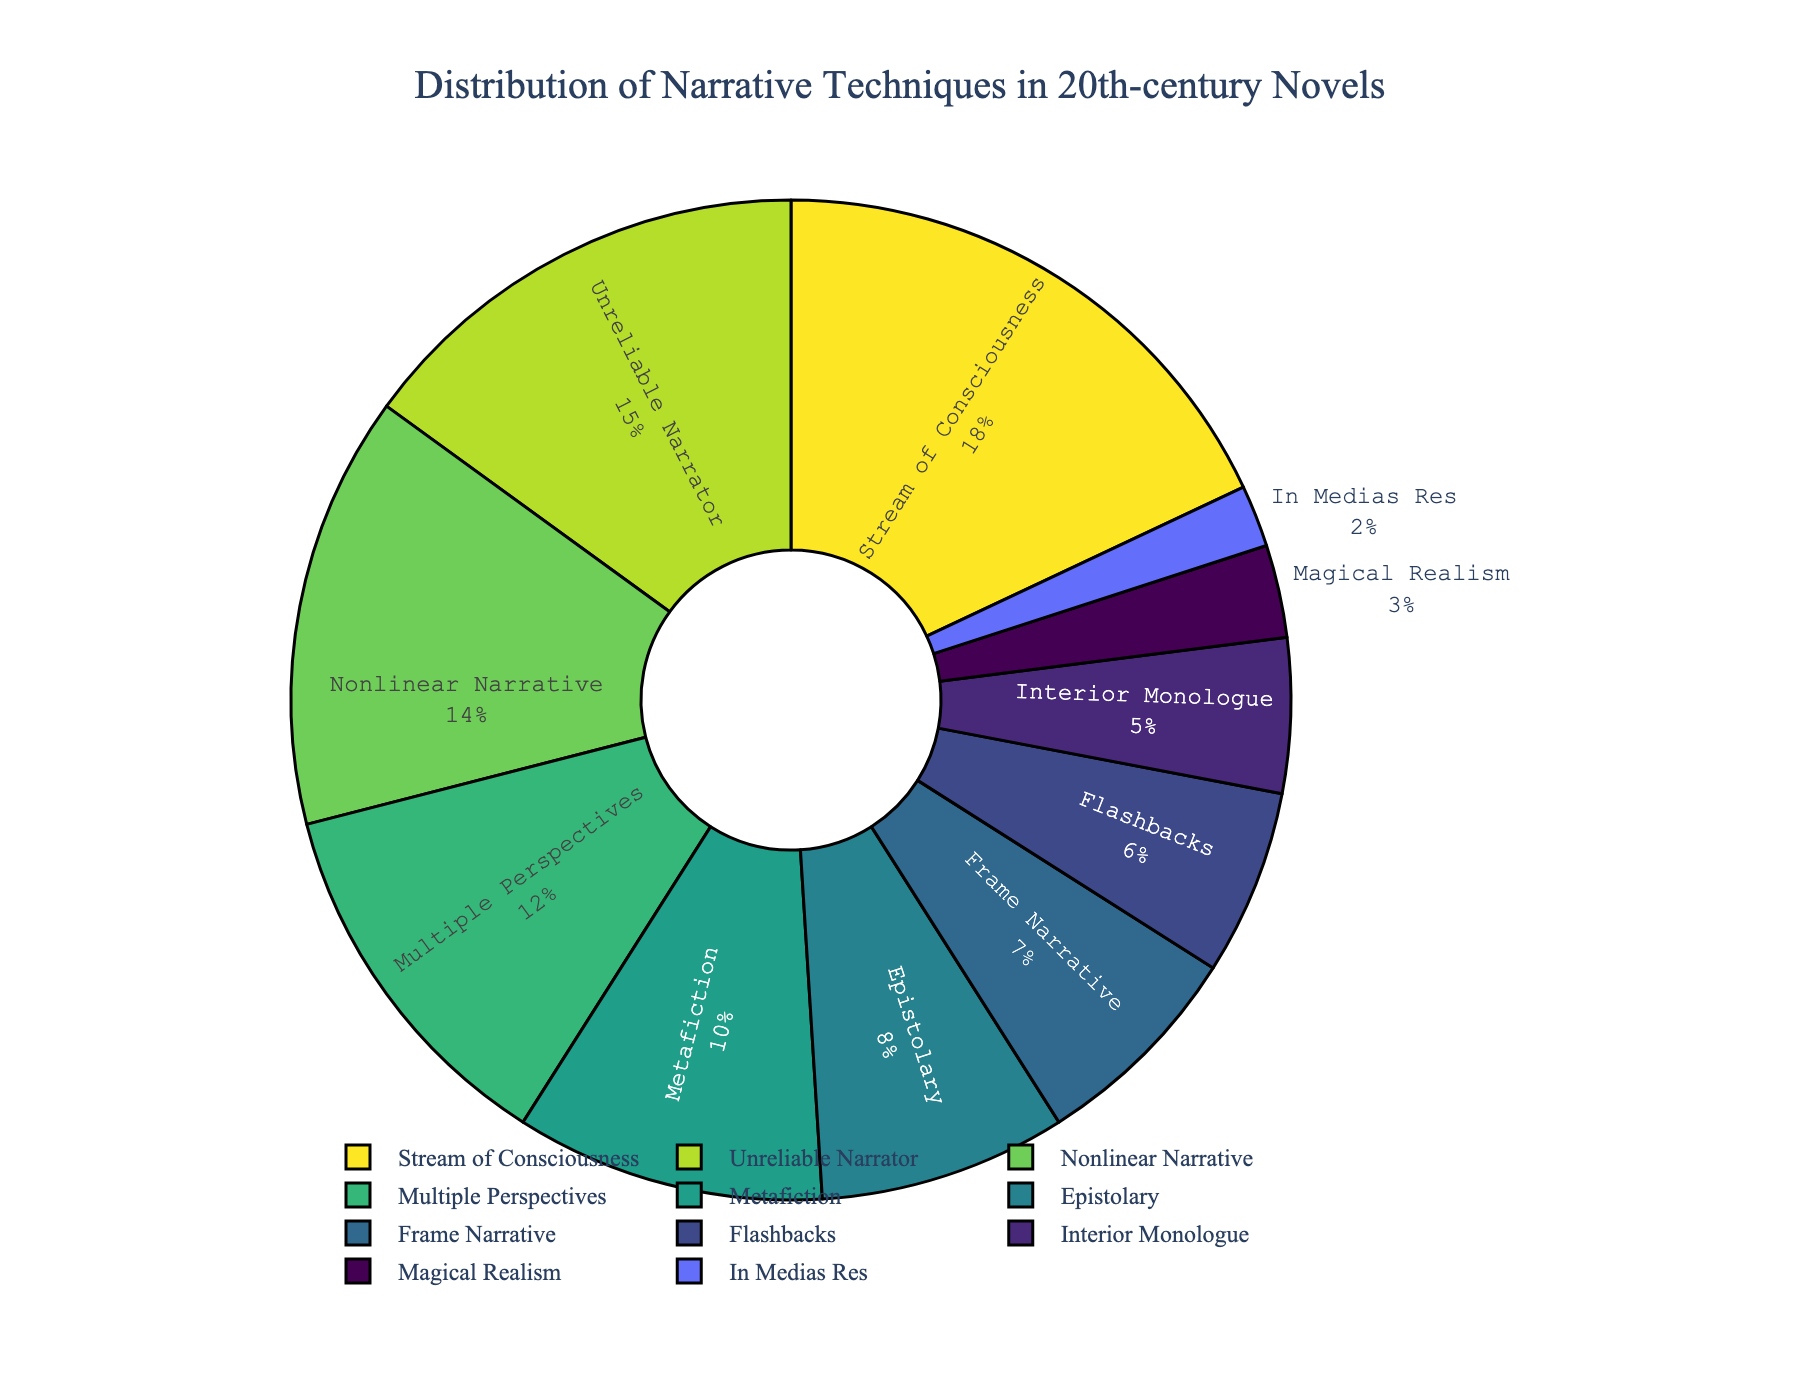Which narrative technique has the highest percentage? The figure shows that "Stream of Consciousness" has the largest slice in the pie chart.
Answer: Stream of Consciousness What is the combined percentage of Nonlinear Narrative and Multiple Perspectives? The figure shows Nonlinear Narrative at 14% and Multiple Perspectives at 12%. Summing these percentages: 14% + 12% = 26%.
Answer: 26% Which technique has a smaller percentage, Frame Narrative or Flashbacks? The figure shows that Frame Narrative is at 7% while Flashbacks is at 6%. Therefore, Flashbacks has a smaller percentage.
Answer: Flashbacks Are there more narrative techniques with a percentage greater than 10% or less than 10%? The techniques greater than 10% are Stream of Consciousness (18%), Unreliable Narrator (15%), Nonlinear Narrative (14%), and Multiple Perspectives (12%), totaling 4 techniques. Techniques less than 10% are Metafiction (10%), Epistolary (8%), Frame Narrative (7%), Flashbacks (6%), Interior Monologue (5%), Magical Realism (3%), and In Medias Res (2%), totaling 7 techniques. Therefore, there are more techniques less than 10%.
Answer: Less than 10% What is the percentage difference between Stream of Consciousness and Unreliable Narrator? The figure shows Stream of Consciousness at 18% and Unreliable Narrator at 15%. The difference is 18% - 15% = 3%.
Answer: 3% Which technique, Metafiction or Epistolary, occupies a larger portion of the pie chart? The figure shows Metafiction at 10% and Epistolary at 8%. Metafiction occupies a larger portion.
Answer: Metafiction How much more do Multiple Perspectives and Nonlinear Narrative together contribute compared to Epistolary? The combined contribution of Multiple Perspectives (12%) and Nonlinear Narrative (14%) is 12% + 14% = 26%. Epistolary is at 8%. The difference is 26% - 8% = 18%.
Answer: 18% Which segments appear closest in size visually? The figure shows that Nonlinear Narrative (14%) and Multiple Perspectives (12%) appear closest in size.
Answer: Nonlinear Narrative and Multiple Perspectives 